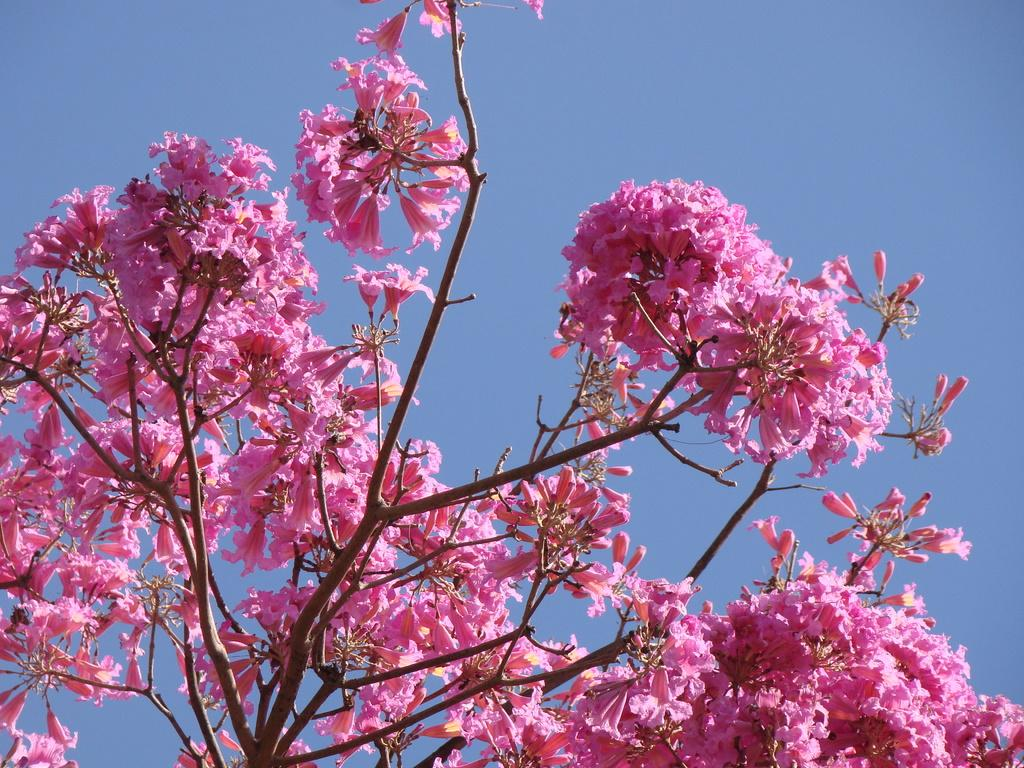Where was the image taken? The image is taken outdoors. What can be seen in the background of the image? There is a sky visible in the background. What type of plant is present in the image? There is a tree in the image. What color are the flowers on the tree? The tree has pink flowers. What type of gun is being used to support the tree in the image? There is no gun present in the image, and the tree is not being supported by any object. 